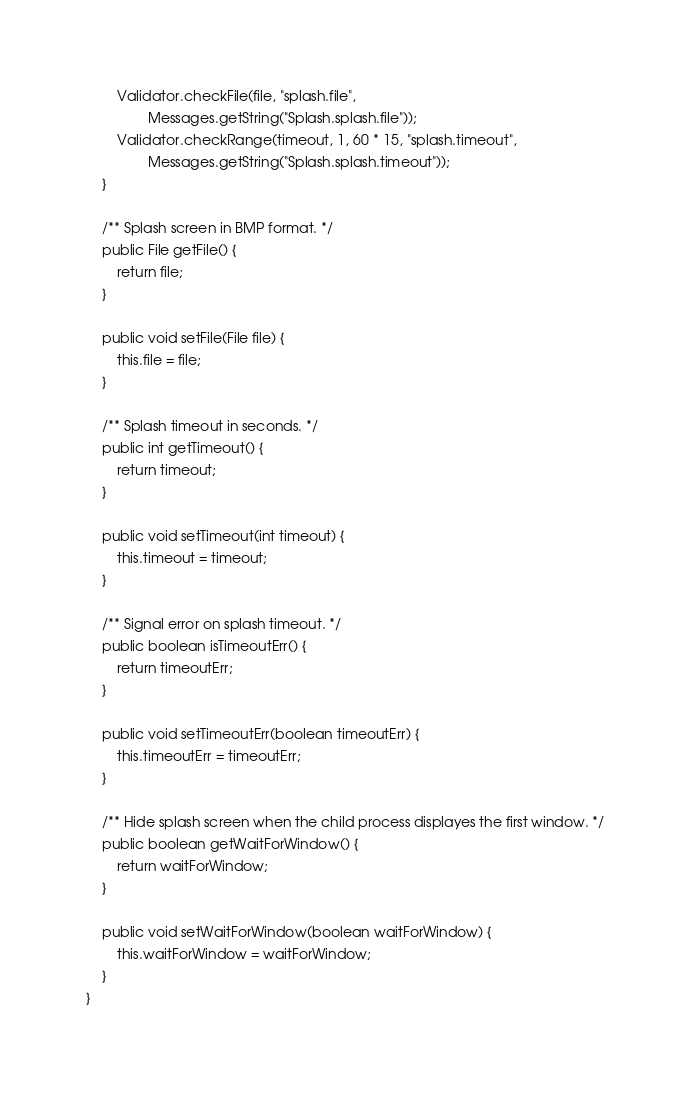Convert code to text. <code><loc_0><loc_0><loc_500><loc_500><_Java_>		Validator.checkFile(file, "splash.file",
				Messages.getString("Splash.splash.file"));
		Validator.checkRange(timeout, 1, 60 * 15, "splash.timeout",
				Messages.getString("Splash.splash.timeout"));
	}

	/** Splash screen in BMP format. */
	public File getFile() {
		return file;
	}

	public void setFile(File file) {
		this.file = file;
	}

	/** Splash timeout in seconds. */
	public int getTimeout() {
		return timeout;
	}

	public void setTimeout(int timeout) {
		this.timeout = timeout;
	}

	/** Signal error on splash timeout. */
	public boolean isTimeoutErr() {
		return timeoutErr;
	}

	public void setTimeoutErr(boolean timeoutErr) {
		this.timeoutErr = timeoutErr;
	}

	/** Hide splash screen when the child process displayes the first window. */
	public boolean getWaitForWindow() {
		return waitForWindow;
	}

	public void setWaitForWindow(boolean waitForWindow) {
		this.waitForWindow = waitForWindow;
	}
}
</code> 